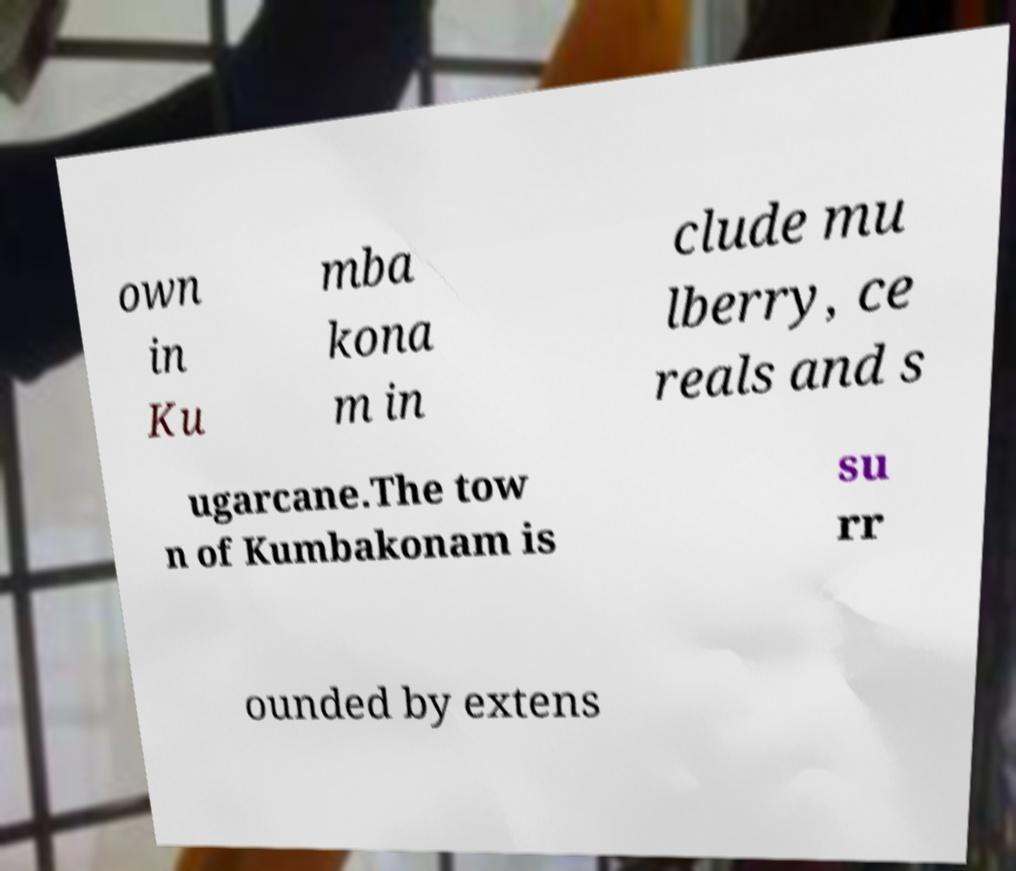I need the written content from this picture converted into text. Can you do that? own in Ku mba kona m in clude mu lberry, ce reals and s ugarcane.The tow n of Kumbakonam is su rr ounded by extens 